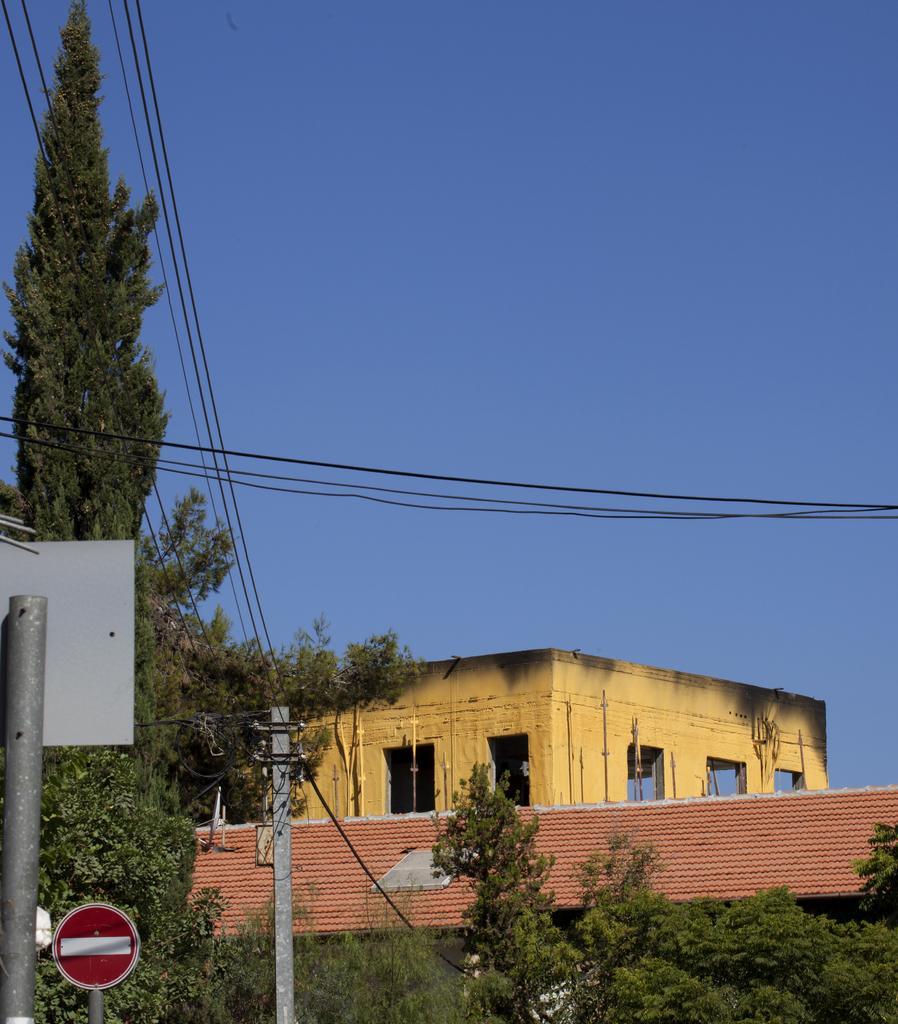Describe this image in one or two sentences. In the picture there are some poles and electrical wires, around them there are many trees and there is a construction beside those trees. 